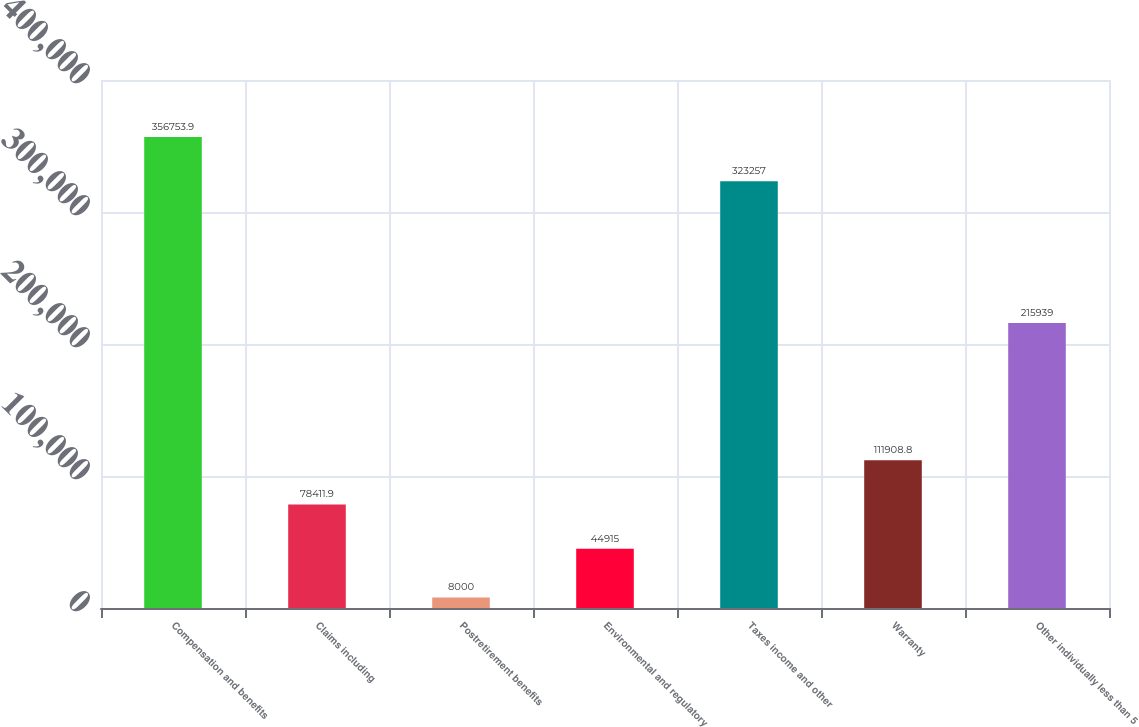Convert chart. <chart><loc_0><loc_0><loc_500><loc_500><bar_chart><fcel>Compensation and benefits<fcel>Claims including<fcel>Postretirement benefits<fcel>Environmental and regulatory<fcel>Taxes income and other<fcel>Warranty<fcel>Other individually less than 5<nl><fcel>356754<fcel>78411.9<fcel>8000<fcel>44915<fcel>323257<fcel>111909<fcel>215939<nl></chart> 